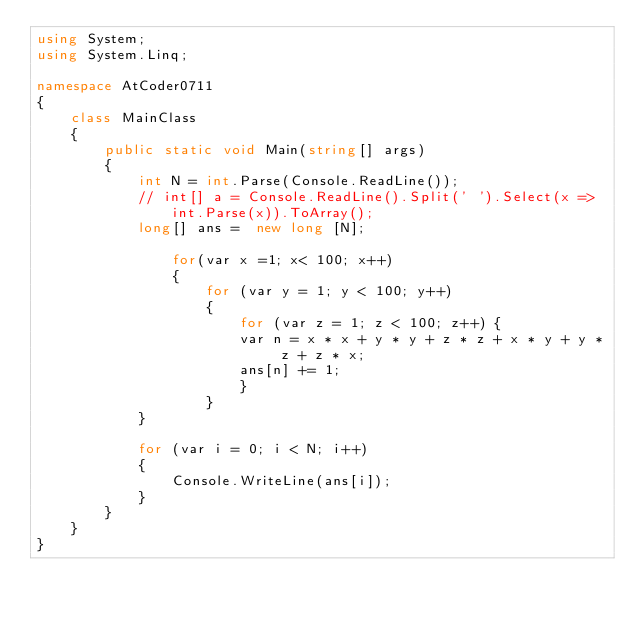Convert code to text. <code><loc_0><loc_0><loc_500><loc_500><_C#_>using System;
using System.Linq;

namespace AtCoder0711
{
    class MainClass
    {
        public static void Main(string[] args)
        {
            int N = int.Parse(Console.ReadLine());
            // int[] a = Console.ReadLine().Split(' ').Select(x => int.Parse(x)).ToArray();
            long[] ans =  new long [N];

                for(var x =1; x< 100; x++)
                {
                    for (var y = 1; y < 100; y++)
                    {
                        for (var z = 1; z < 100; z++) {
                        var n = x * x + y * y + z * z + x * y + y * z + z * x;
                        ans[n] += 1;
                        }
                    }
            }

            for (var i = 0; i < N; i++)
            {
                Console.WriteLine(ans[i]);
            }
        }
    }
}
</code> 